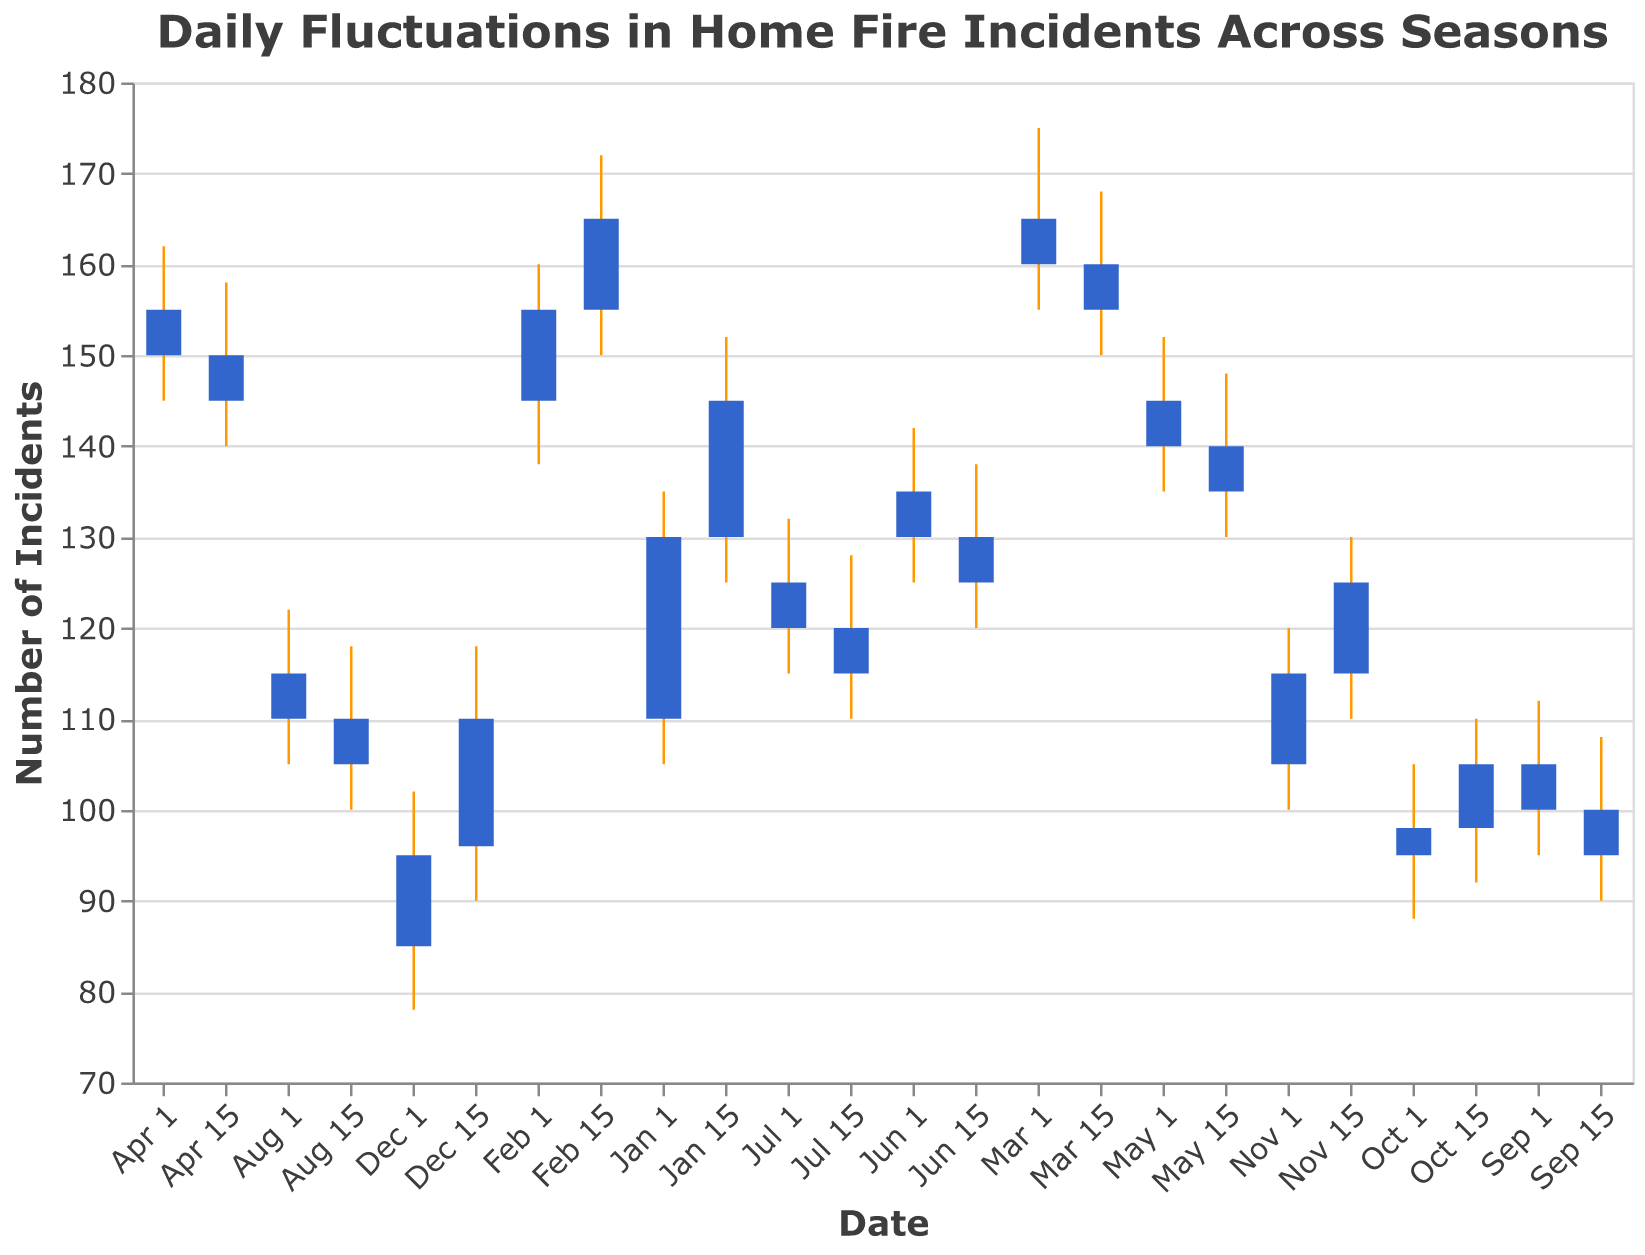what is the title of the chart? The title of the chart is displayed at the top and is written in bold with the font "Verdana".
Answer: Daily Fluctuations in Home Fire Incidents Across Seasons How many peaks are observed in the Home Fire Incidents during the Winter months? The Winter months include December, January, and February. Observing the data points for these months shows peaks or the highest values in each candlestick: Dec 1 has a high of 102, Dec 15 has 118, Jan 1 has 135, Jan 15 has 152, Feb 1 has 160, and Feb 15 has 172.
Answer: 6 What is the 'High' value on Dec 15? Look for the data point corresponding to Dec 15 and identify the 'High' value for this date.
Answer: 118 By how much did the 'Close' value change between Feb 15 and Mar 15? Find the 'Close' value for both dates (Feb 15: 165, Mar 15: 155) and calculate the difference by subtracting the 'Close' value of Mar 15 from Feb 15.
Answer: 10 Which month showed the least fluctuation in home fire incidents based on the highest (High) minus the lowest (Low) values? Compare the difference between the 'High' and 'Low' values for each date. The month with the smallest difference will represent the least fluctuation. For example, calculate the following differences: Dec 1: 102-78=24, Dec 15: 118-90=28, and so forth. The month with the smallest difference (Jul 15: 128-110=18) indicates the least fluctuation.
Answer: July On what date did the 'Close' value exceed the 'Open' value by the largest amount during the Winter months? Look at the 'Close' and 'Open' values for all dates in December, January, and February, calculate the differences, e.g., Dec 1: Close(95) - Open(85) = 10, Dec 15: Close(110) - Open(96) = 14. The date with the largest positive difference is Feb 15 with a difference of 165-155=10.
Answer: Feb 15 What is the average 'High' value for the dates in January? Calculate the average of the 'High' values for Jan 1 (135) and Jan 15 (152). (135 + 152) / 2 = 143.5
Answer: 143.5 How many different colors are used in the chart and what do they represent? Identify the number of different colors and their representation; there are two colors used: orange for the lines indicating the range from 'Low' to 'High' and blue for the bars representing the range from 'Open' to 'Close'.
Answer: 2 colors, orange and blue When was the highest 'High' value recorded and what was it? Scan through the 'High' values for all dates and identify the highest one. The highest 'High' value is on Feb 15 with 172.
Answer: Feb 15, 172 What pattern is observed in the 'Close' values from February to April? Look at the 'Close' values for Feb, Mar, and Apr; we can observe a declining trend. Specifically, the values decrease from 165 (Feb 15), to 160 (Mar 1), to 155 (Mar 15), to 150 (Apr 1), and to 145 (Apr 15).
Answer: Declining trend 